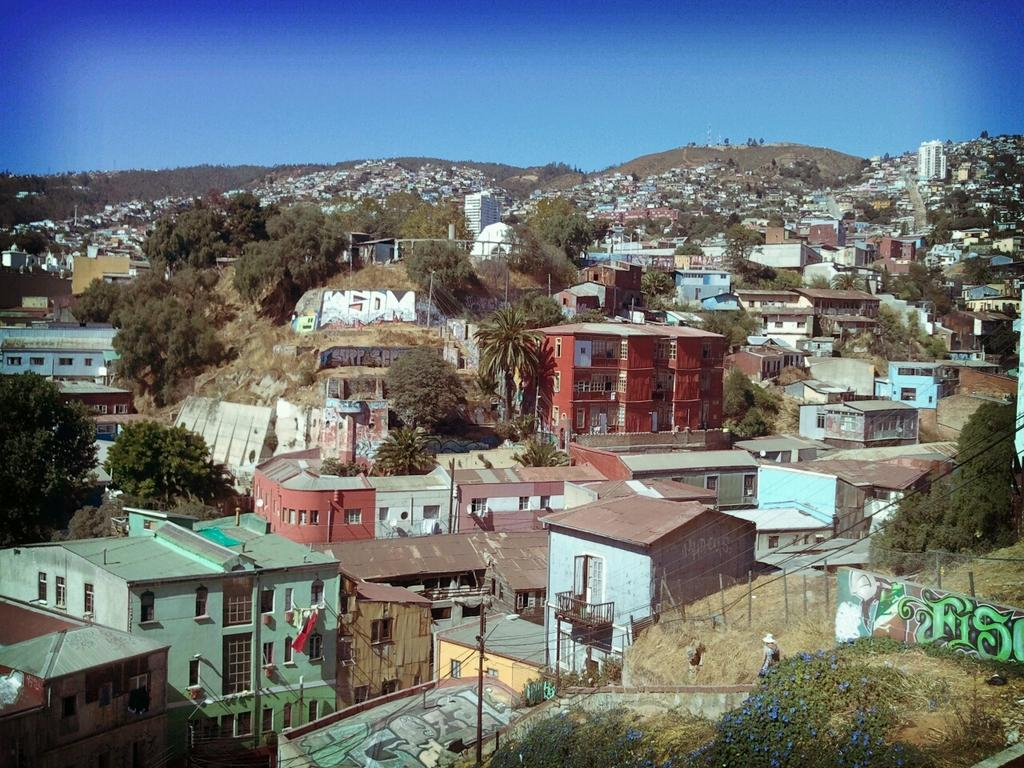What type of structures can be seen in the image? There are buildings in the image. What type of vegetation is present in the image? There are trees in the image. What other objects can be seen in the image? There are utility poles in the image. What type of ground cover is visible in the image? There is grass in the image. What type of natural landform is visible in the image? There are mountains in the image. What part of the natural environment is visible in the image? The sky is visible in the image. What type of dinner is being served in the image? There is no dinner present in the image; it features buildings, trees, utility poles, grass, mountains, and the sky. How does the wave affect the buildings in the image? There is no wave present in the image; it features buildings, trees, utility poles, grass, mountains, and the sky. 